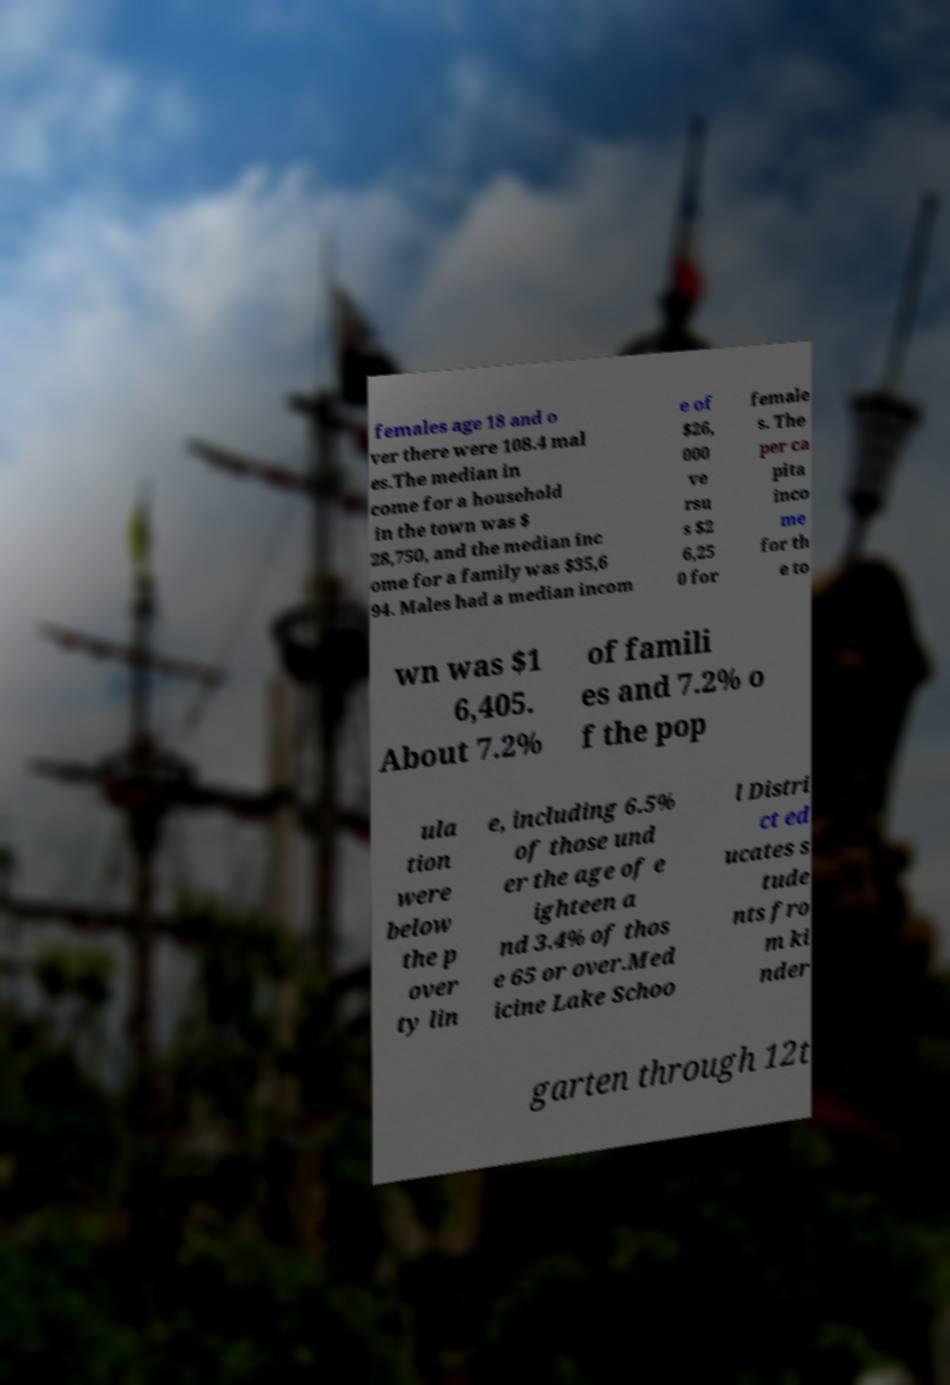I need the written content from this picture converted into text. Can you do that? females age 18 and o ver there were 108.4 mal es.The median in come for a household in the town was $ 28,750, and the median inc ome for a family was $35,6 94. Males had a median incom e of $26, 000 ve rsu s $2 6,25 0 for female s. The per ca pita inco me for th e to wn was $1 6,405. About 7.2% of famili es and 7.2% o f the pop ula tion were below the p over ty lin e, including 6.5% of those und er the age of e ighteen a nd 3.4% of thos e 65 or over.Med icine Lake Schoo l Distri ct ed ucates s tude nts fro m ki nder garten through 12t 